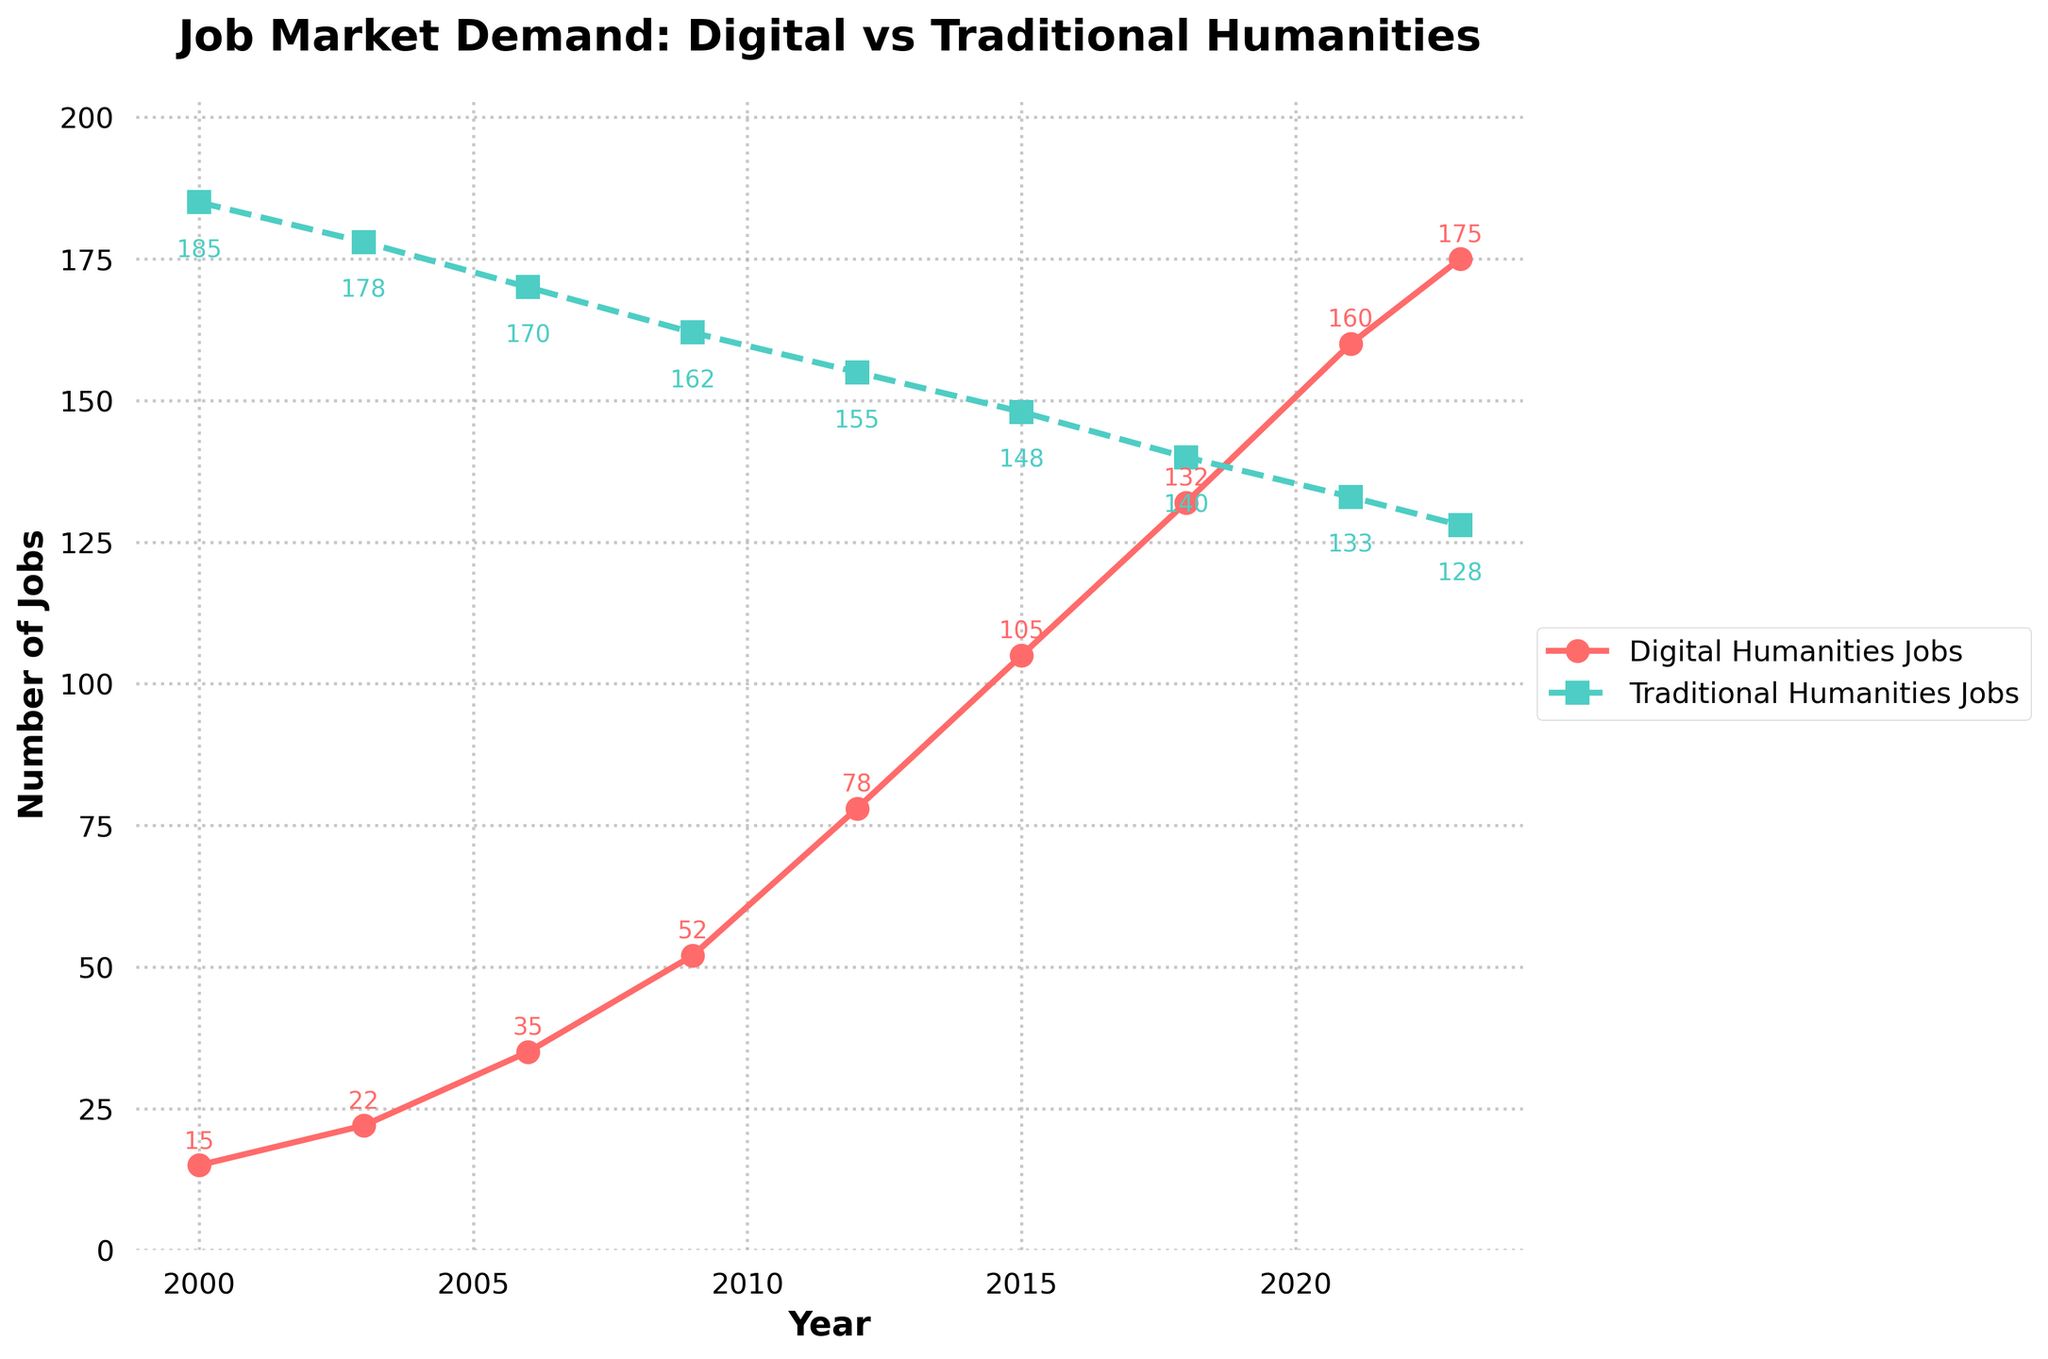What is the overall trend in the number of digital humanities jobs from 2000 to 2023? The number of digital humanities jobs shows a consistent upward trend from 15 in 2000 to 175 in 2023. Each successive year sees growth, indicating increasing demand.
Answer: Increasing trend How does the number of traditional humanities jobs in 2009 compare to the number in 2023? In 2009, there were 162 traditional humanities jobs, while in 2023 there are 128. Subtracting the values, 162 - 128 = 34, shows a decrease by 34 jobs.
Answer: 34 fewer jobs Which year saw the highest number of digital humanities jobs, and how many jobs were there? By observing the peak of the red line with circles, the year 2023 saw the highest number of digital humanities jobs, which was 175.
Answer: 2023, 175 jobs What is the difference in the number of digital humanities jobs between 2012 and 2023? In 2012, there were 78 digital humanities jobs and in 2023, there were 175. The difference is calculated as 175 - 78 = 97.
Answer: 97 jobs In what year did the number of digital humanities jobs first surpass 100? The red line first crosses the 100 mark in the year 2015 with 105 digital humanities jobs.
Answer: 2015 Compare the number of traditional humanities jobs in 2000 and 2023. In 2000, there were 185 traditional humanities jobs and in 2023, there were 128. The difference is calculated as 185 - 128 = 57.
Answer: 57 fewer jobs What is the average number of digital humanities jobs between 2000 and 2023 inclusive? Sum the digital humanities jobs over the years (15+22+35+52+78+105+132+160+175)=774, divided by the number of years (9). The average is 774 / 9 ≈ 86.
Answer: 86 How do the trends for digital humanities jobs and traditional humanities jobs differ over this period? Digital humanities jobs consistently increase, while traditional humanities jobs steadily decrease. This suggests a shifting market preference towards digital humanities skills over time.
Answer: Increasing vs. decreasing How much did the number of traditional humanities jobs change from 2000 to 2006, both in magnitude and direction? In 2000, there were 185 traditional humanities jobs, and by 2006, there were 170. The change is 185 - 170 = 15 jobs, which indicates a decrease.
Answer: Decrease by 15 jobs Which has a higher value in 2021: digital humanities jobs or traditional humanities jobs? By how much? In 2021, there were 160 digital humanities jobs and 133 traditional humanities jobs. The difference is calculated as 160 - 133 = 27, showing digital humanities jobs have 27 more.
Answer: Digital humanities by 27 